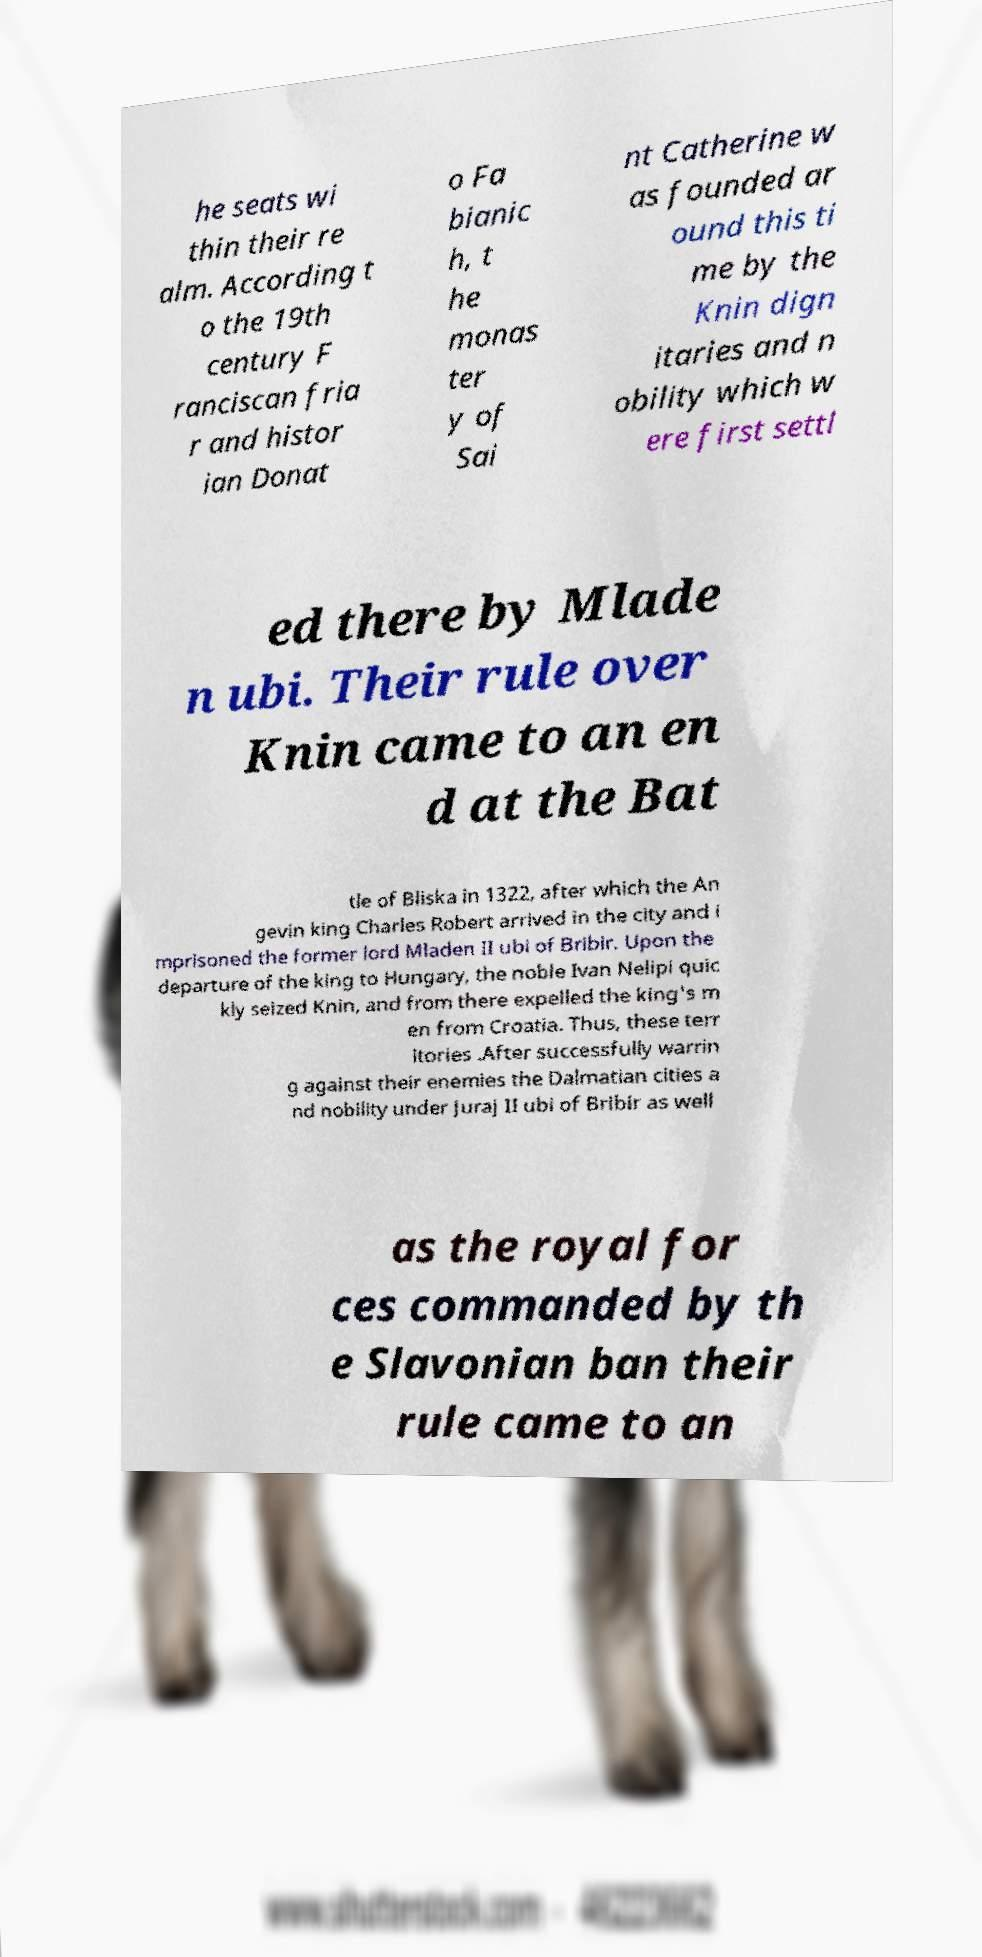For documentation purposes, I need the text within this image transcribed. Could you provide that? he seats wi thin their re alm. According t o the 19th century F ranciscan fria r and histor ian Donat o Fa bianic h, t he monas ter y of Sai nt Catherine w as founded ar ound this ti me by the Knin dign itaries and n obility which w ere first settl ed there by Mlade n ubi. Their rule over Knin came to an en d at the Bat tle of Bliska in 1322, after which the An gevin king Charles Robert arrived in the city and i mprisoned the former lord Mladen II ubi of Bribir. Upon the departure of the king to Hungary, the noble Ivan Nelipi quic kly seized Knin, and from there expelled the king's m en from Croatia. Thus, these terr itories .After successfully warrin g against their enemies the Dalmatian cities a nd nobility under Juraj II ubi of Bribir as well as the royal for ces commanded by th e Slavonian ban their rule came to an 